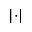Convert formula to latex. <formula><loc_0><loc_0><loc_500><loc_500>\left | \cdot \right |</formula> 